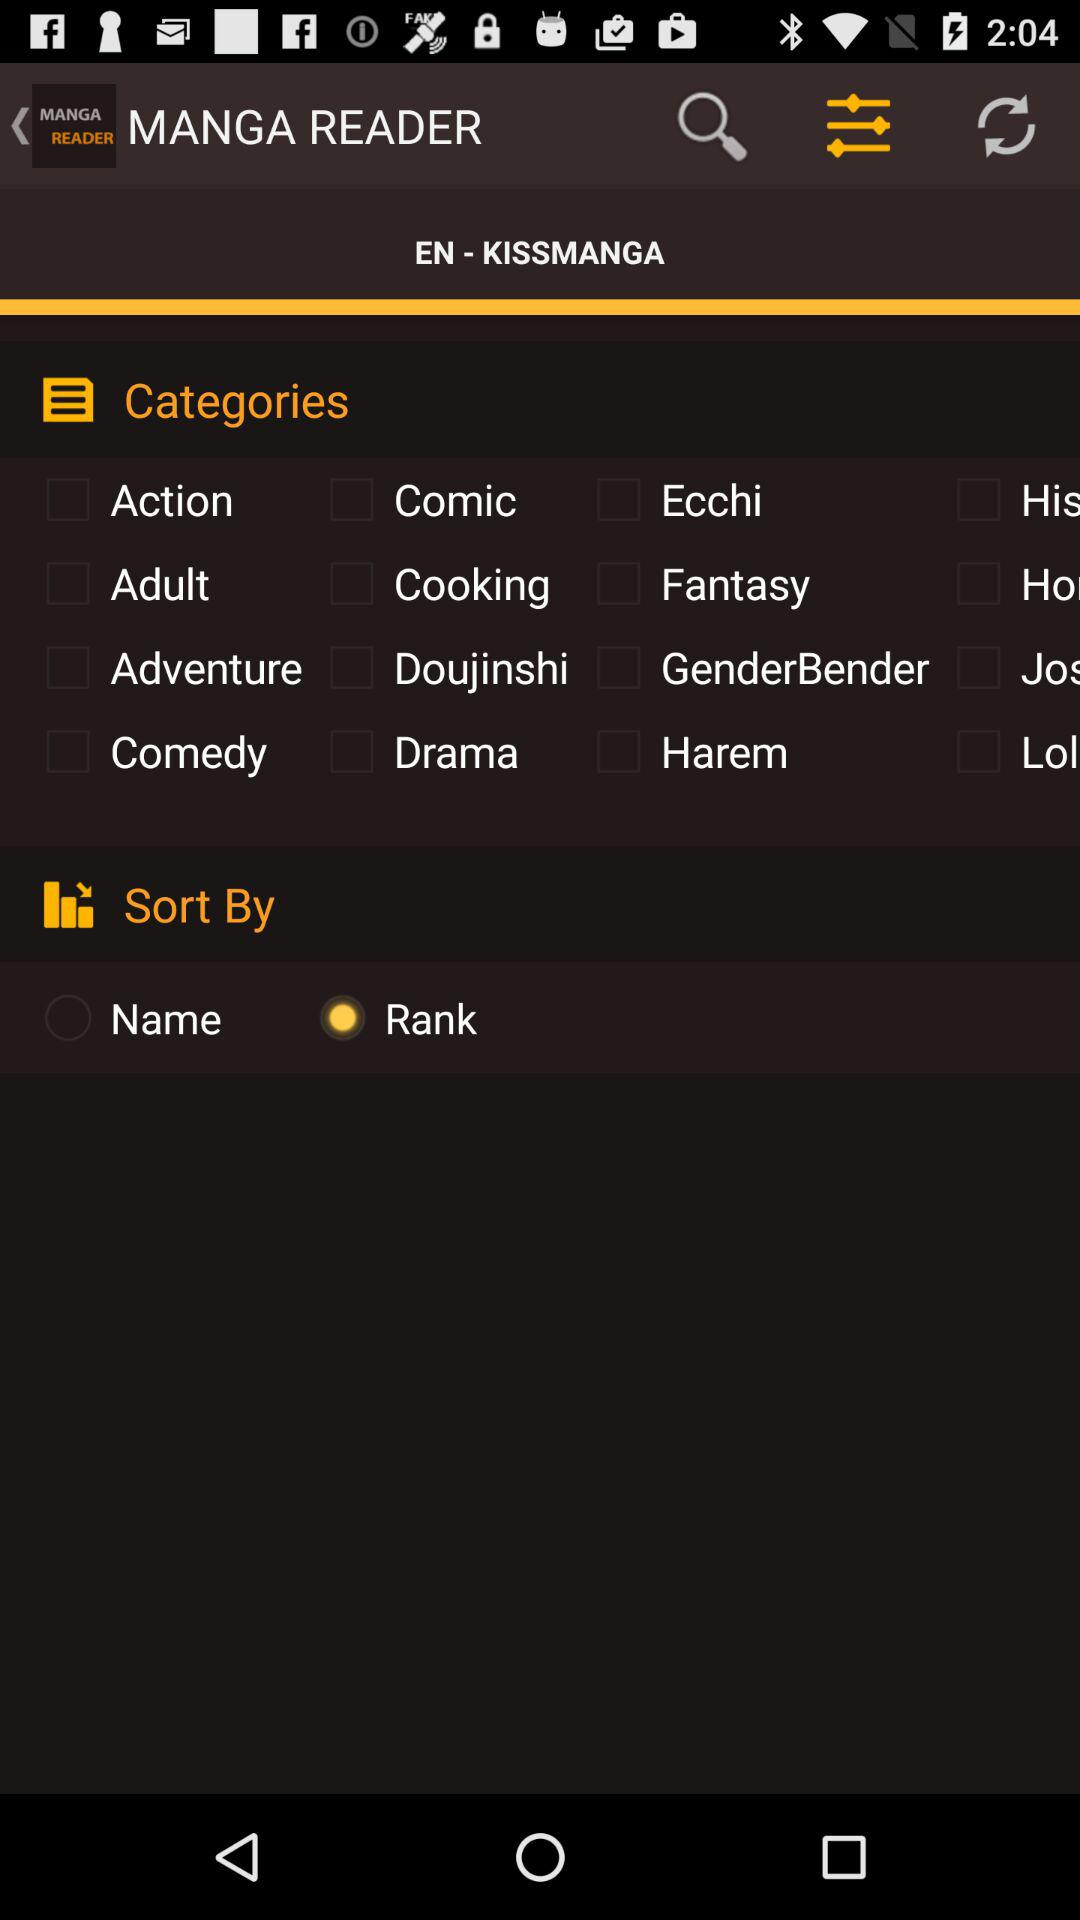What is the app name? The app name is "MANGA READER". 